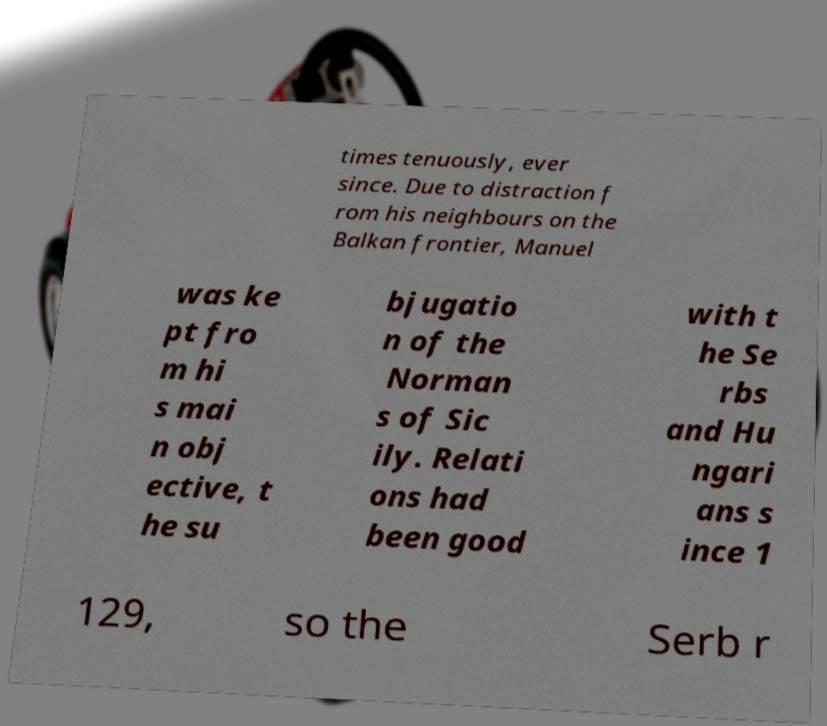Can you accurately transcribe the text from the provided image for me? times tenuously, ever since. Due to distraction f rom his neighbours on the Balkan frontier, Manuel was ke pt fro m hi s mai n obj ective, t he su bjugatio n of the Norman s of Sic ily. Relati ons had been good with t he Se rbs and Hu ngari ans s ince 1 129, so the Serb r 